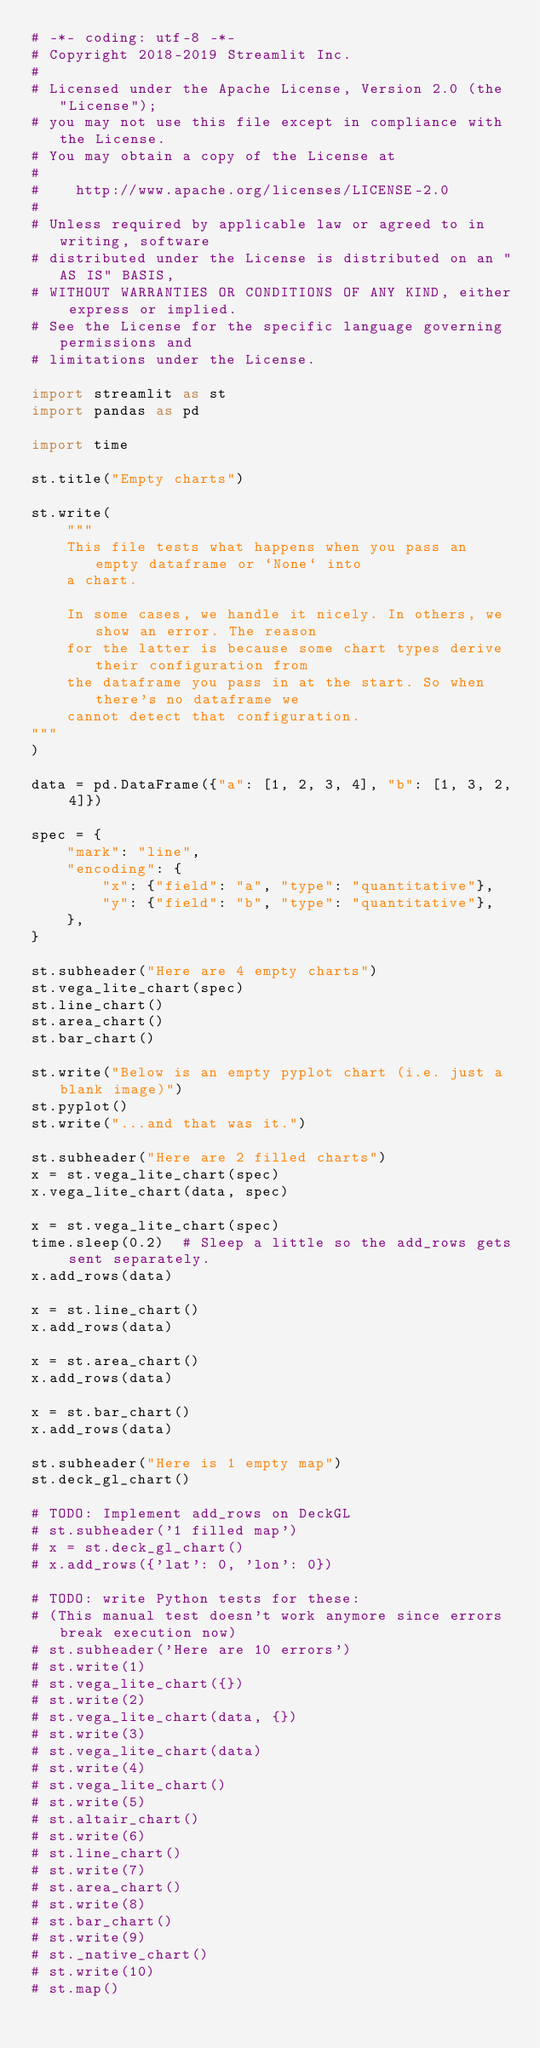<code> <loc_0><loc_0><loc_500><loc_500><_Python_># -*- coding: utf-8 -*-
# Copyright 2018-2019 Streamlit Inc.
#
# Licensed under the Apache License, Version 2.0 (the "License");
# you may not use this file except in compliance with the License.
# You may obtain a copy of the License at
#
#    http://www.apache.org/licenses/LICENSE-2.0
#
# Unless required by applicable law or agreed to in writing, software
# distributed under the License is distributed on an "AS IS" BASIS,
# WITHOUT WARRANTIES OR CONDITIONS OF ANY KIND, either express or implied.
# See the License for the specific language governing permissions and
# limitations under the License.

import streamlit as st
import pandas as pd

import time

st.title("Empty charts")

st.write(
    """
    This file tests what happens when you pass an empty dataframe or `None` into
    a chart.

    In some cases, we handle it nicely. In others, we show an error. The reason
    for the latter is because some chart types derive their configuration from
    the dataframe you pass in at the start. So when there's no dataframe we
    cannot detect that configuration.
"""
)

data = pd.DataFrame({"a": [1, 2, 3, 4], "b": [1, 3, 2, 4]})

spec = {
    "mark": "line",
    "encoding": {
        "x": {"field": "a", "type": "quantitative"},
        "y": {"field": "b", "type": "quantitative"},
    },
}

st.subheader("Here are 4 empty charts")
st.vega_lite_chart(spec)
st.line_chart()
st.area_chart()
st.bar_chart()

st.write("Below is an empty pyplot chart (i.e. just a blank image)")
st.pyplot()
st.write("...and that was it.")

st.subheader("Here are 2 filled charts")
x = st.vega_lite_chart(spec)
x.vega_lite_chart(data, spec)

x = st.vega_lite_chart(spec)
time.sleep(0.2)  # Sleep a little so the add_rows gets sent separately.
x.add_rows(data)

x = st.line_chart()
x.add_rows(data)

x = st.area_chart()
x.add_rows(data)

x = st.bar_chart()
x.add_rows(data)

st.subheader("Here is 1 empty map")
st.deck_gl_chart()

# TODO: Implement add_rows on DeckGL
# st.subheader('1 filled map')
# x = st.deck_gl_chart()
# x.add_rows({'lat': 0, 'lon': 0})

# TODO: write Python tests for these:
# (This manual test doesn't work anymore since errors break execution now)
# st.subheader('Here are 10 errors')
# st.write(1)
# st.vega_lite_chart({})
# st.write(2)
# st.vega_lite_chart(data, {})
# st.write(3)
# st.vega_lite_chart(data)
# st.write(4)
# st.vega_lite_chart()
# st.write(5)
# st.altair_chart()
# st.write(6)
# st.line_chart()
# st.write(7)
# st.area_chart()
# st.write(8)
# st.bar_chart()
# st.write(9)
# st._native_chart()
# st.write(10)
# st.map()
</code> 